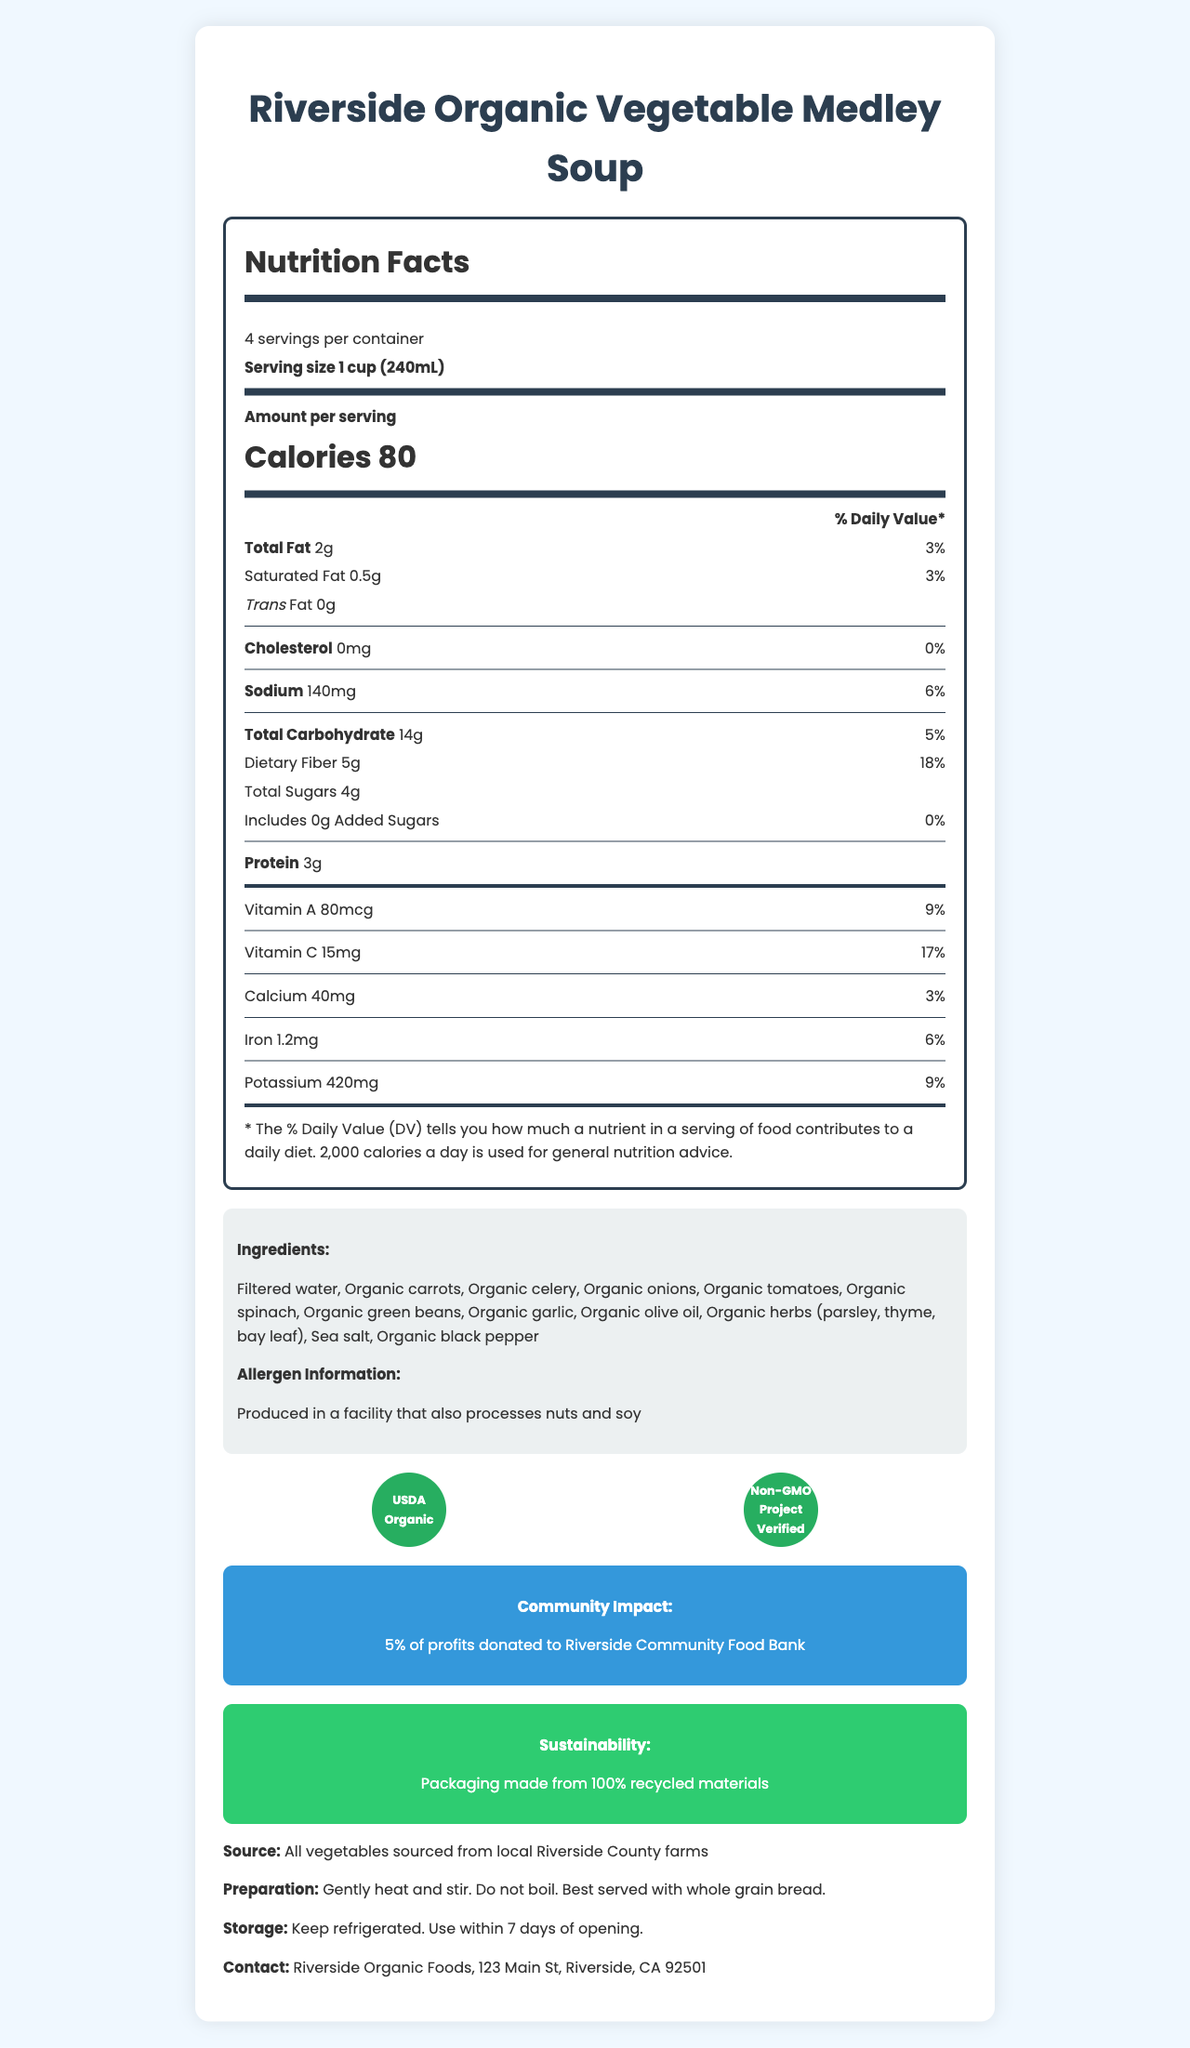what is the serving size? The serving size is clearly listed as "1 cup (240mL)" in the nutrition facts section.
Answer: 1 cup (240mL) how many servings are in the container? The document states there are 4 servings per container in the nutrition facts section.
Answer: 4 what is the total fat content per serving? It is indicated in the nutrition facts that the total fat content per serving is 2g.
Answer: 2g how much dietary fiber is in one serving? The nutrition facts mention that each serving contains 5g of dietary fiber.
Answer: 5g what is the amount of sodium per serving? The amount of sodium per serving is listed as 140mg in the nutrition facts.
Answer: 140mg which nutrient has a daily value percentage of 18%? A. Sodium B. Total Carbohydrate C. Dietary Fiber D. Protein The nutrition facts section shows that the dietary fiber has a percent daily value of 18%.
Answer: C. Dietary Fiber what is the percent daily value of Vitamin C per serving? A. 9% B. 17% C. 6% D. 3% According to the nutrition facts, the percent daily value for Vitamin C per serving is 17%.
Answer: B. 17% is there any trans fat in this soup? The document indicates that there is 0g of trans fat per serving.
Answer: No describe the sustainability practices mentioned. The document explicitly states that the packaging for the soup is made from 100% recycled materials.
Answer: The soup's packaging is made from 100% recycled materials. how much added sugar does the soup contain? It is mentioned in the nutrition facts that there is 0g of added sugars.
Answer: 0g what certifications does this product have? The document lists USDA Organic and Non-GMO Project Verified as the certifications.
Answer: USDA Organic, Non-GMO Project Verified what is the community impact of purchasing this soup? The community impact section states that 5% of the profits are donated to the Riverside Community Food Bank.
Answer: 5% of profits donated to Riverside Community Food Bank can the preparation instructions be found in the document? The document includes preparation tips stating to gently heat and stir the soup and not to boil it.
Answer: Yes how many calories are in one serving? The nutrition facts mention that each serving contains 80 calories.
Answer: 80 where are the vegetables in the soup sourced from? The document states all vegetables are sourced from local Riverside County farms.
Answer: Local Riverside County farms describe the main idea of this document. The main idea of the document centers around offering detailed information about the organic soup, including its nutritional value, ingredients, and various certifications supporting its quality and commitment to the community and environment.
Answer: The document provides the nutrition facts, ingredients, allergen information, certifications, community impact, sustainability practices, source information, preparation tips, storage instructions, and contact information for Riverside Organic Vegetable Medley Soup. what is the production method for this soup? The document does not specify the exact production method or process used for making the soup.
Answer: Not enough information 